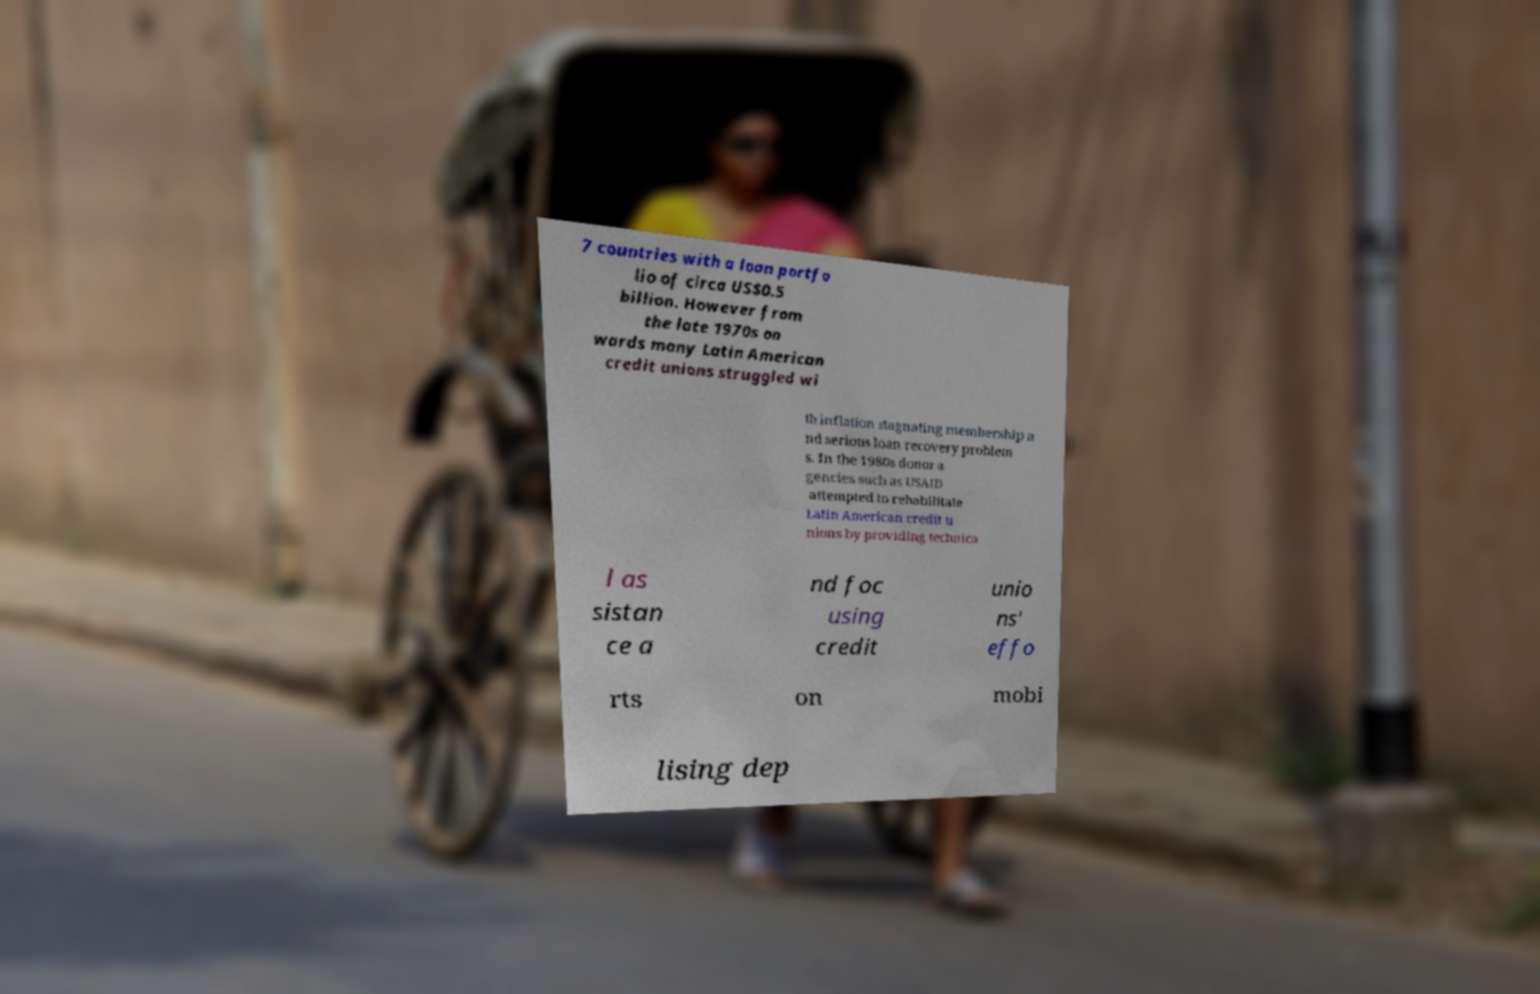There's text embedded in this image that I need extracted. Can you transcribe it verbatim? 7 countries with a loan portfo lio of circa US$0.5 billion. However from the late 1970s on wards many Latin American credit unions struggled wi th inflation stagnating membership a nd serious loan recovery problem s. In the 1980s donor a gencies such as USAID attempted to rehabilitate Latin American credit u nions by providing technica l as sistan ce a nd foc using credit unio ns' effo rts on mobi lising dep 